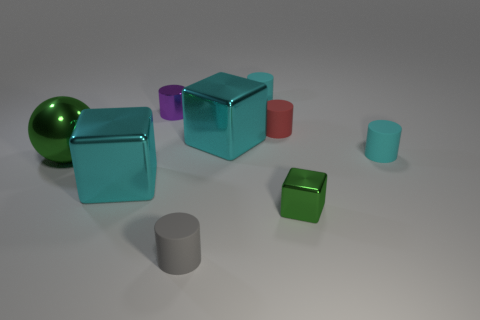Is the color of the large sphere the same as the small metal block?
Your answer should be very brief. Yes. There is a large metallic ball that is in front of the purple thing; is its color the same as the tiny cube?
Make the answer very short. Yes. There is a metallic object that is the same color as the ball; what shape is it?
Your answer should be compact. Cube. Are there any other things that are the same shape as the large green metallic thing?
Offer a very short reply. No. Are there the same number of cyan objects left of the tiny purple object and tiny gray matte objects?
Make the answer very short. Yes. There is a small gray cylinder; are there any tiny matte cylinders left of it?
Ensure brevity in your answer.  No. What size is the green metallic object to the left of the small cyan object that is to the left of the green metal object in front of the big green metallic ball?
Keep it short and to the point. Large. There is a green thing right of the tiny gray cylinder; is it the same shape as the big metallic thing in front of the big green metal sphere?
Keep it short and to the point. Yes. There is a gray matte object that is the same shape as the tiny red rubber object; what is its size?
Give a very brief answer. Small. How many other objects have the same material as the small red object?
Provide a succinct answer. 3. 